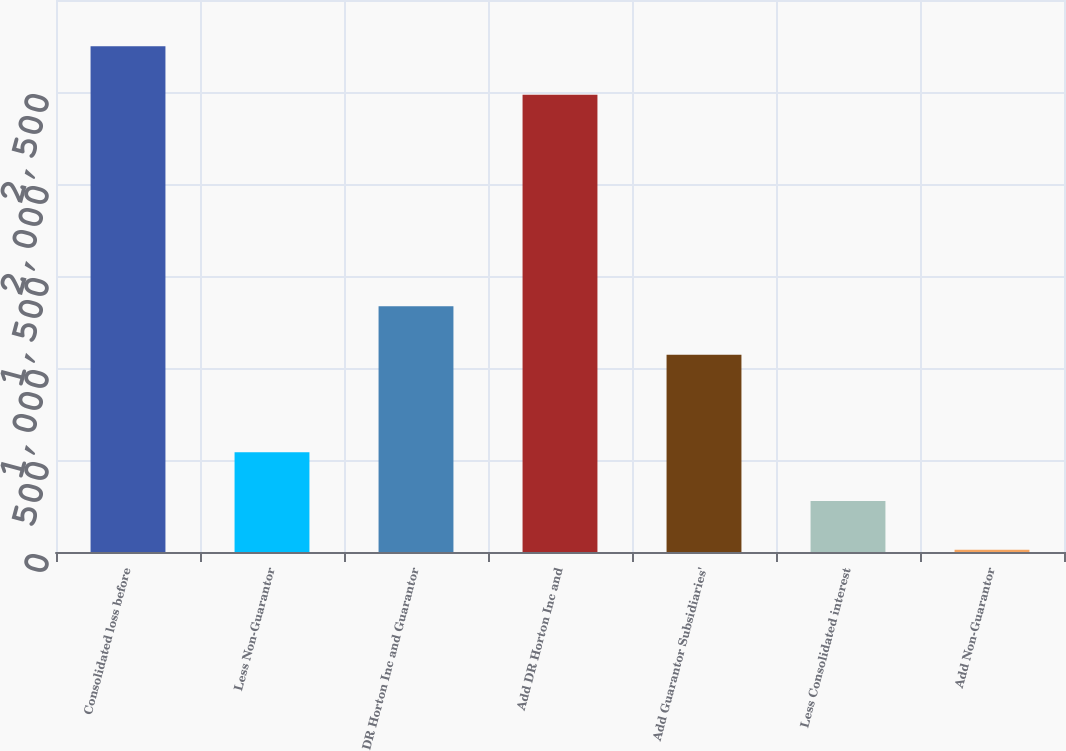Convert chart. <chart><loc_0><loc_0><loc_500><loc_500><bar_chart><fcel>Consolidated loss before<fcel>Less Non-Guarantor<fcel>DR Horton Inc and Guarantor<fcel>Add DR Horton Inc and<fcel>Add Guarantor Subsidiaries'<fcel>Less Consolidated interest<fcel>Add Non-Guarantor<nl><fcel>2749.24<fcel>541.98<fcel>1336.2<fcel>2484.5<fcel>1071.46<fcel>277.24<fcel>12.5<nl></chart> 